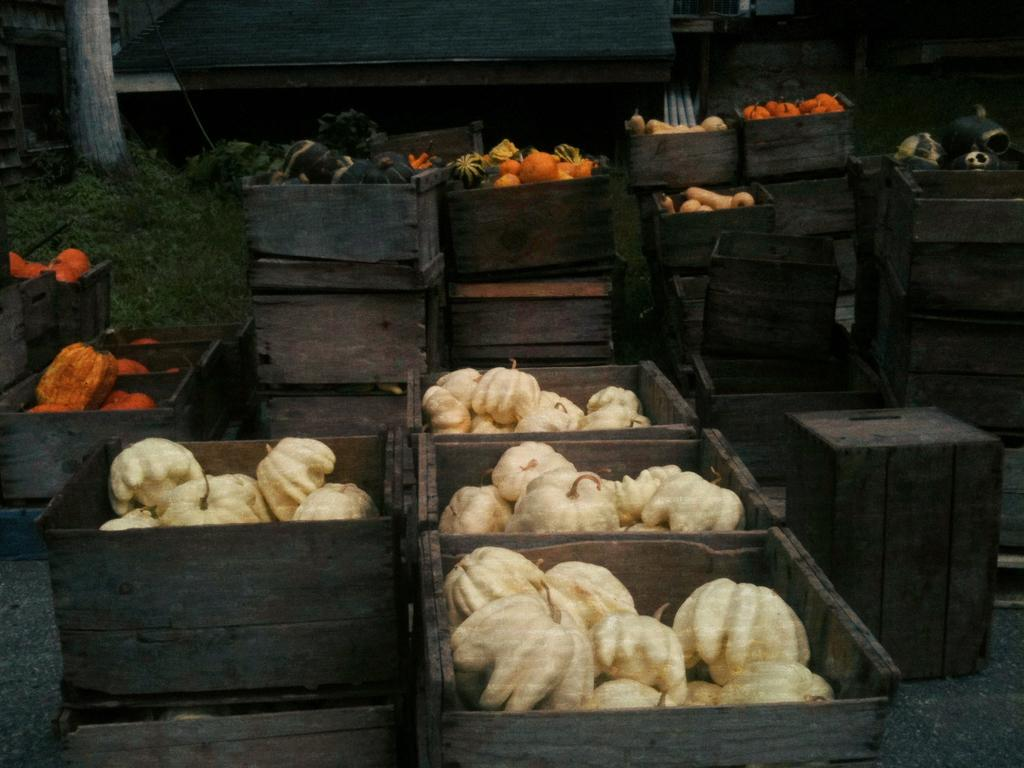What type of food items are in the wooden boxes in the image? There are vegetables in wooden boxes in the image. What else can be seen growing in the image? There are plants visible in the image. What type of natural vegetation is visible in the image? There are trees visible in the image. What type of human-made structures are visible in the image? There are houses visible in the image. What type of notebook is being used by the mother in the image? There is no mother or notebook present in the image. What type of flame can be seen coming from the trees in the image? There is no flame present in the image; it features vegetables, plants, trees, and houses. 